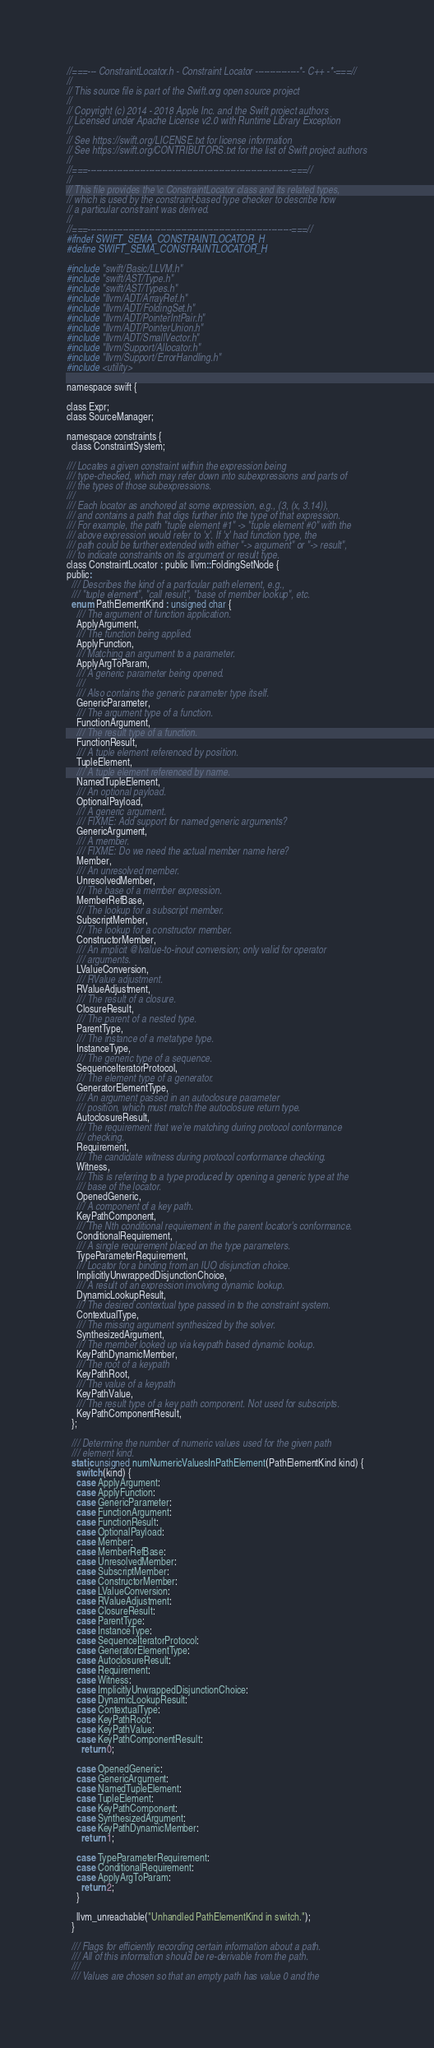<code> <loc_0><loc_0><loc_500><loc_500><_C_>//===--- ConstraintLocator.h - Constraint Locator ---------------*- C++ -*-===//
//
// This source file is part of the Swift.org open source project
//
// Copyright (c) 2014 - 2018 Apple Inc. and the Swift project authors
// Licensed under Apache License v2.0 with Runtime Library Exception
//
// See https://swift.org/LICENSE.txt for license information
// See https://swift.org/CONTRIBUTORS.txt for the list of Swift project authors
//
//===----------------------------------------------------------------------===//
//
// This file provides the \c ConstraintLocator class and its related types,
// which is used by the constraint-based type checker to describe how
// a particular constraint was derived.
//
//===----------------------------------------------------------------------===//
#ifndef SWIFT_SEMA_CONSTRAINTLOCATOR_H
#define SWIFT_SEMA_CONSTRAINTLOCATOR_H

#include "swift/Basic/LLVM.h"
#include "swift/AST/Type.h"
#include "swift/AST/Types.h"
#include "llvm/ADT/ArrayRef.h"
#include "llvm/ADT/FoldingSet.h"
#include "llvm/ADT/PointerIntPair.h"
#include "llvm/ADT/PointerUnion.h"
#include "llvm/ADT/SmallVector.h"
#include "llvm/Support/Allocator.h"
#include "llvm/Support/ErrorHandling.h"
#include <utility>

namespace swift {

class Expr;
class SourceManager;

namespace constraints {
  class ConstraintSystem;

/// Locates a given constraint within the expression being
/// type-checked, which may refer down into subexpressions and parts of
/// the types of those subexpressions.
///
/// Each locator as anchored at some expression, e.g., (3, (x, 3.14)),
/// and contains a path that digs further into the type of that expression.
/// For example, the path "tuple element #1" -> "tuple element #0" with the
/// above expression would refer to 'x'. If 'x' had function type, the
/// path could be further extended with either "-> argument" or "-> result",
/// to indicate constraints on its argument or result type.
class ConstraintLocator : public llvm::FoldingSetNode {
public:
  /// Describes the kind of a particular path element, e.g.,
  /// "tuple element", "call result", "base of member lookup", etc.
  enum PathElementKind : unsigned char {
    /// The argument of function application.
    ApplyArgument,
    /// The function being applied.
    ApplyFunction,
    /// Matching an argument to a parameter.
    ApplyArgToParam,
    /// A generic parameter being opened.
    ///
    /// Also contains the generic parameter type itself.
    GenericParameter,
    /// The argument type of a function.
    FunctionArgument,
    /// The result type of a function.
    FunctionResult,
    /// A tuple element referenced by position.
    TupleElement,
    /// A tuple element referenced by name.
    NamedTupleElement,
    /// An optional payload.
    OptionalPayload,
    /// A generic argument.
    /// FIXME: Add support for named generic arguments?
    GenericArgument,
    /// A member.
    /// FIXME: Do we need the actual member name here?
    Member,
    /// An unresolved member.
    UnresolvedMember,
    /// The base of a member expression.
    MemberRefBase,
    /// The lookup for a subscript member.
    SubscriptMember,
    /// The lookup for a constructor member.
    ConstructorMember,
    /// An implicit @lvalue-to-inout conversion; only valid for operator
    /// arguments.
    LValueConversion,
    /// RValue adjustment.
    RValueAdjustment,
    /// The result of a closure.
    ClosureResult,
    /// The parent of a nested type.
    ParentType,
    /// The instance of a metatype type.
    InstanceType,
    /// The generic type of a sequence.
    SequenceIteratorProtocol,
    /// The element type of a generator.
    GeneratorElementType,
    /// An argument passed in an autoclosure parameter
    /// position, which must match the autoclosure return type.
    AutoclosureResult,
    /// The requirement that we're matching during protocol conformance
    /// checking.
    Requirement,
    /// The candidate witness during protocol conformance checking.
    Witness,
    /// This is referring to a type produced by opening a generic type at the
    /// base of the locator.
    OpenedGeneric,
    /// A component of a key path.
    KeyPathComponent,
    /// The Nth conditional requirement in the parent locator's conformance.
    ConditionalRequirement,
    /// A single requirement placed on the type parameters.
    TypeParameterRequirement,
    /// Locator for a binding from an IUO disjunction choice.
    ImplicitlyUnwrappedDisjunctionChoice,
    /// A result of an expression involving dynamic lookup.
    DynamicLookupResult,
    /// The desired contextual type passed in to the constraint system.
    ContextualType,
    /// The missing argument synthesized by the solver.
    SynthesizedArgument,
    /// The member looked up via keypath based dynamic lookup.
    KeyPathDynamicMember,
    /// The root of a keypath
    KeyPathRoot,
    /// The value of a keypath
    KeyPathValue,
    /// The result type of a key path component. Not used for subscripts.
    KeyPathComponentResult,
  };

  /// Determine the number of numeric values used for the given path
  /// element kind.
  static unsigned numNumericValuesInPathElement(PathElementKind kind) {
    switch (kind) {
    case ApplyArgument:
    case ApplyFunction:
    case GenericParameter:
    case FunctionArgument:
    case FunctionResult:
    case OptionalPayload:
    case Member:
    case MemberRefBase:
    case UnresolvedMember:
    case SubscriptMember:
    case ConstructorMember:
    case LValueConversion:
    case RValueAdjustment:
    case ClosureResult:
    case ParentType:
    case InstanceType:
    case SequenceIteratorProtocol:
    case GeneratorElementType:
    case AutoclosureResult:
    case Requirement:
    case Witness:
    case ImplicitlyUnwrappedDisjunctionChoice:
    case DynamicLookupResult:
    case ContextualType:
    case KeyPathRoot:
    case KeyPathValue:
    case KeyPathComponentResult:
      return 0;

    case OpenedGeneric:
    case GenericArgument:
    case NamedTupleElement:
    case TupleElement:
    case KeyPathComponent:
    case SynthesizedArgument:
    case KeyPathDynamicMember:
      return 1;

    case TypeParameterRequirement:
    case ConditionalRequirement:
    case ApplyArgToParam:
      return 2;
    }

    llvm_unreachable("Unhandled PathElementKind in switch.");
  }

  /// Flags for efficiently recording certain information about a path.
  /// All of this information should be re-derivable from the path.
  ///
  /// Values are chosen so that an empty path has value 0 and the</code> 